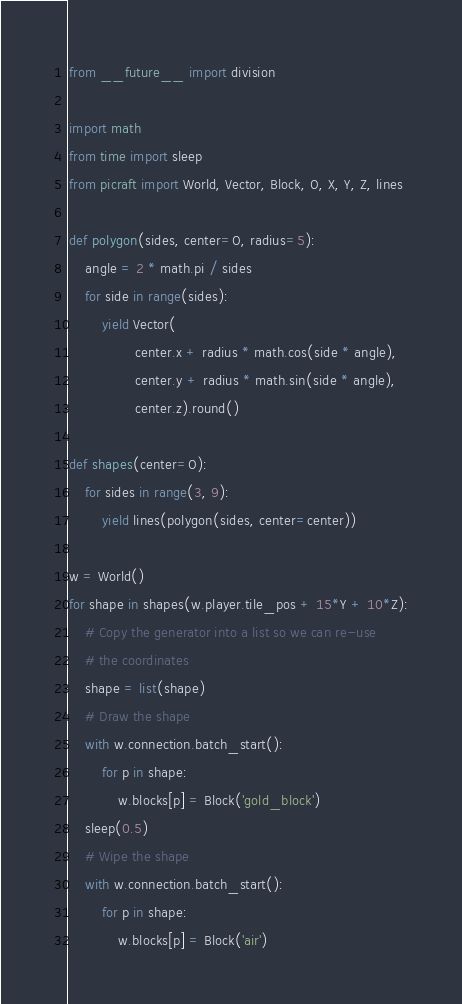<code> <loc_0><loc_0><loc_500><loc_500><_Python_>from __future__ import division

import math
from time import sleep
from picraft import World, Vector, Block, O, X, Y, Z, lines

def polygon(sides, center=O, radius=5):
    angle = 2 * math.pi / sides
    for side in range(sides):
        yield Vector(
                center.x + radius * math.cos(side * angle),
                center.y + radius * math.sin(side * angle),
                center.z).round()

def shapes(center=O):
    for sides in range(3, 9):
        yield lines(polygon(sides, center=center))

w = World()
for shape in shapes(w.player.tile_pos + 15*Y + 10*Z):
    # Copy the generator into a list so we can re-use
    # the coordinates
    shape = list(shape)
    # Draw the shape
    with w.connection.batch_start():
        for p in shape:
            w.blocks[p] = Block('gold_block')
    sleep(0.5)
    # Wipe the shape
    with w.connection.batch_start():
        for p in shape:
            w.blocks[p] = Block('air')
</code> 